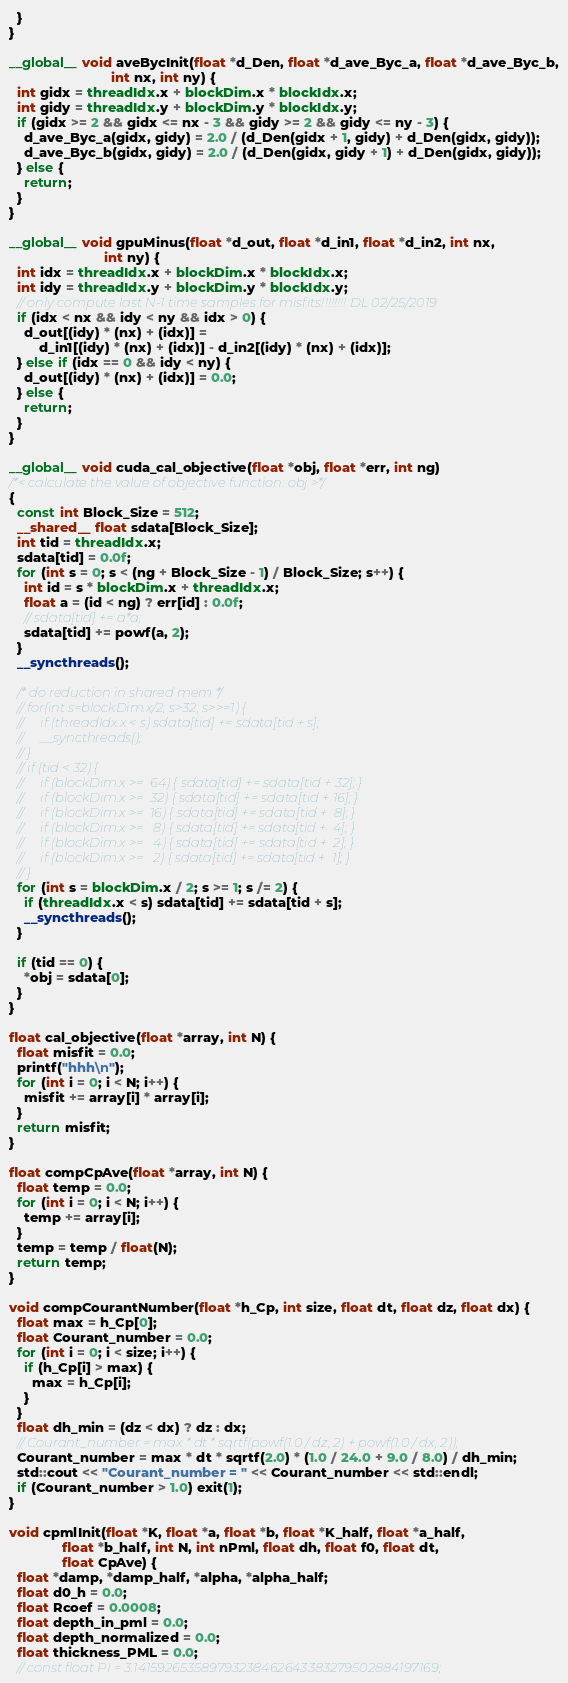Convert code to text. <code><loc_0><loc_0><loc_500><loc_500><_Cuda_>  }
}

__global__ void aveBycInit(float *d_Den, float *d_ave_Byc_a, float *d_ave_Byc_b,
                           int nx, int ny) {
  int gidx = threadIdx.x + blockDim.x * blockIdx.x;
  int gidy = threadIdx.y + blockDim.y * blockIdx.y;
  if (gidx >= 2 && gidx <= nx - 3 && gidy >= 2 && gidy <= ny - 3) {
    d_ave_Byc_a(gidx, gidy) = 2.0 / (d_Den(gidx + 1, gidy) + d_Den(gidx, gidy));
    d_ave_Byc_b(gidx, gidy) = 2.0 / (d_Den(gidx, gidy + 1) + d_Den(gidx, gidy));
  } else {
    return;
  }
}

__global__ void gpuMinus(float *d_out, float *d_in1, float *d_in2, int nx,
                         int ny) {
  int idx = threadIdx.x + blockDim.x * blockIdx.x;
  int idy = threadIdx.y + blockDim.y * blockIdx.y;
  // only compute last N-1 time samples for misfits!!!!!!!! DL 02/25/2019
  if (idx < nx && idy < ny && idx > 0) {
    d_out[(idy) * (nx) + (idx)] =
        d_in1[(idy) * (nx) + (idx)] - d_in2[(idy) * (nx) + (idx)];
  } else if (idx == 0 && idy < ny) {
    d_out[(idy) * (nx) + (idx)] = 0.0;
  } else {
    return;
  }
}

__global__ void cuda_cal_objective(float *obj, float *err, int ng)
/*< calculate the value of objective function: obj >*/
{
  const int Block_Size = 512;
  __shared__ float sdata[Block_Size];
  int tid = threadIdx.x;
  sdata[tid] = 0.0f;
  for (int s = 0; s < (ng + Block_Size - 1) / Block_Size; s++) {
    int id = s * blockDim.x + threadIdx.x;
    float a = (id < ng) ? err[id] : 0.0f;
    // sdata[tid] += a*a;
    sdata[tid] += powf(a, 2);
  }
  __syncthreads();

  /* do reduction in shared mem */
  // for(int s=blockDim.x/2; s>32; s>>=1) {
  //     if (threadIdx.x < s) sdata[tid] += sdata[tid + s];
  //     __syncthreads();
  // }
  // if (tid < 32) {
  //     if (blockDim.x >=  64) { sdata[tid] += sdata[tid + 32]; }
  //     if (blockDim.x >=  32) { sdata[tid] += sdata[tid + 16]; }
  //     if (blockDim.x >=  16) { sdata[tid] += sdata[tid +  8]; }
  //     if (blockDim.x >=   8) { sdata[tid] += sdata[tid +  4]; }
  //     if (blockDim.x >=   4) { sdata[tid] += sdata[tid +  2]; }
  //     if (blockDim.x >=   2) { sdata[tid] += sdata[tid +  1]; }
  // }
  for (int s = blockDim.x / 2; s >= 1; s /= 2) {
    if (threadIdx.x < s) sdata[tid] += sdata[tid + s];
    __syncthreads();
  }

  if (tid == 0) {
    *obj = sdata[0];
  }
}

float cal_objective(float *array, int N) {
  float misfit = 0.0;
  printf("hhh\n");
  for (int i = 0; i < N; i++) {
    misfit += array[i] * array[i];
  }
  return misfit;
}

float compCpAve(float *array, int N) {
  float temp = 0.0;
  for (int i = 0; i < N; i++) {
    temp += array[i];
  }
  temp = temp / float(N);
  return temp;
}

void compCourantNumber(float *h_Cp, int size, float dt, float dz, float dx) {
  float max = h_Cp[0];
  float Courant_number = 0.0;
  for (int i = 0; i < size; i++) {
    if (h_Cp[i] > max) {
      max = h_Cp[i];
    }
  }
  float dh_min = (dz < dx) ? dz : dx;
  // Courant_number = max * dt * sqrtf(powf(1.0 / dz, 2) + powf(1.0 / dx, 2));
  Courant_number = max * dt * sqrtf(2.0) * (1.0 / 24.0 + 9.0 / 8.0) / dh_min;
  std::cout << "Courant_number = " << Courant_number << std::endl;
  if (Courant_number > 1.0) exit(1);
}

void cpmlInit(float *K, float *a, float *b, float *K_half, float *a_half,
              float *b_half, int N, int nPml, float dh, float f0, float dt,
              float CpAve) {
  float *damp, *damp_half, *alpha, *alpha_half;
  float d0_h = 0.0;
  float Rcoef = 0.0008;
  float depth_in_pml = 0.0;
  float depth_normalized = 0.0;
  float thickness_PML = 0.0;
  // const float PI = 3.141592653589793238462643383279502884197169;</code> 